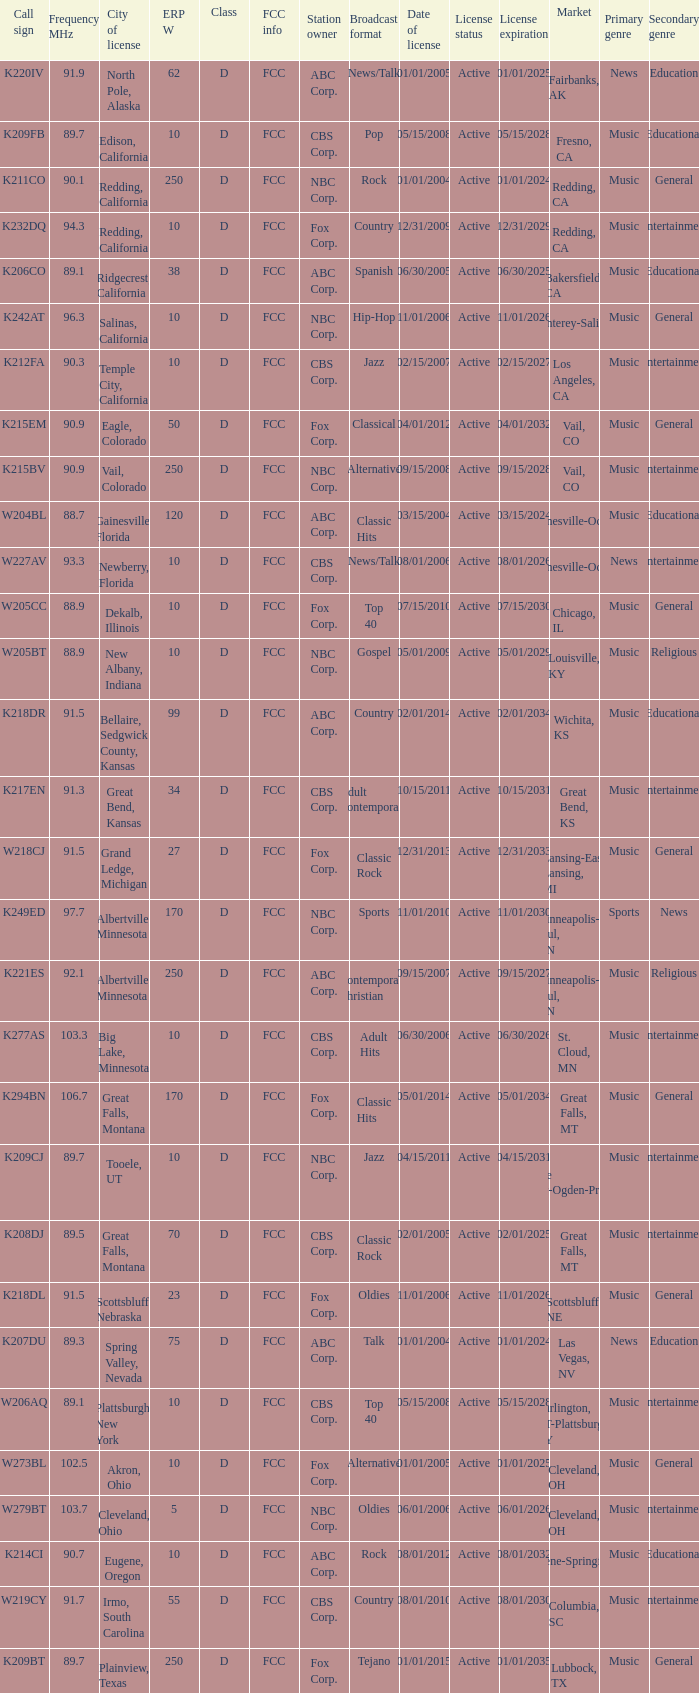What is the call sign of the translator in Spring Valley, Nevada? K207DU. 